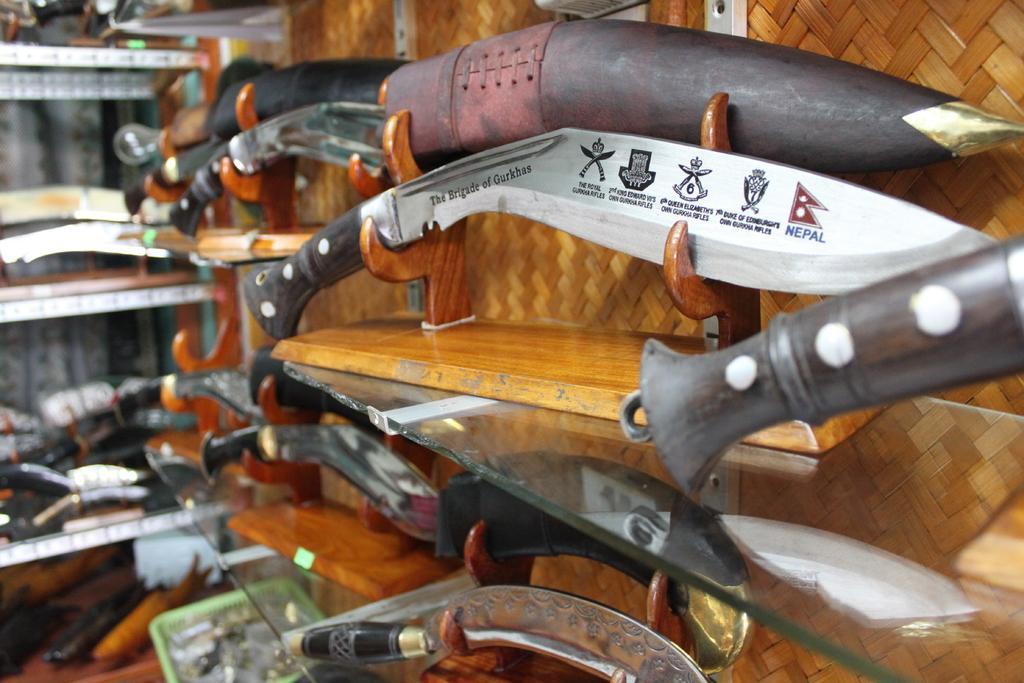Please provide a concise description of this image. In this image I can see knives. In the background I can see shelf which has some objects on it. 